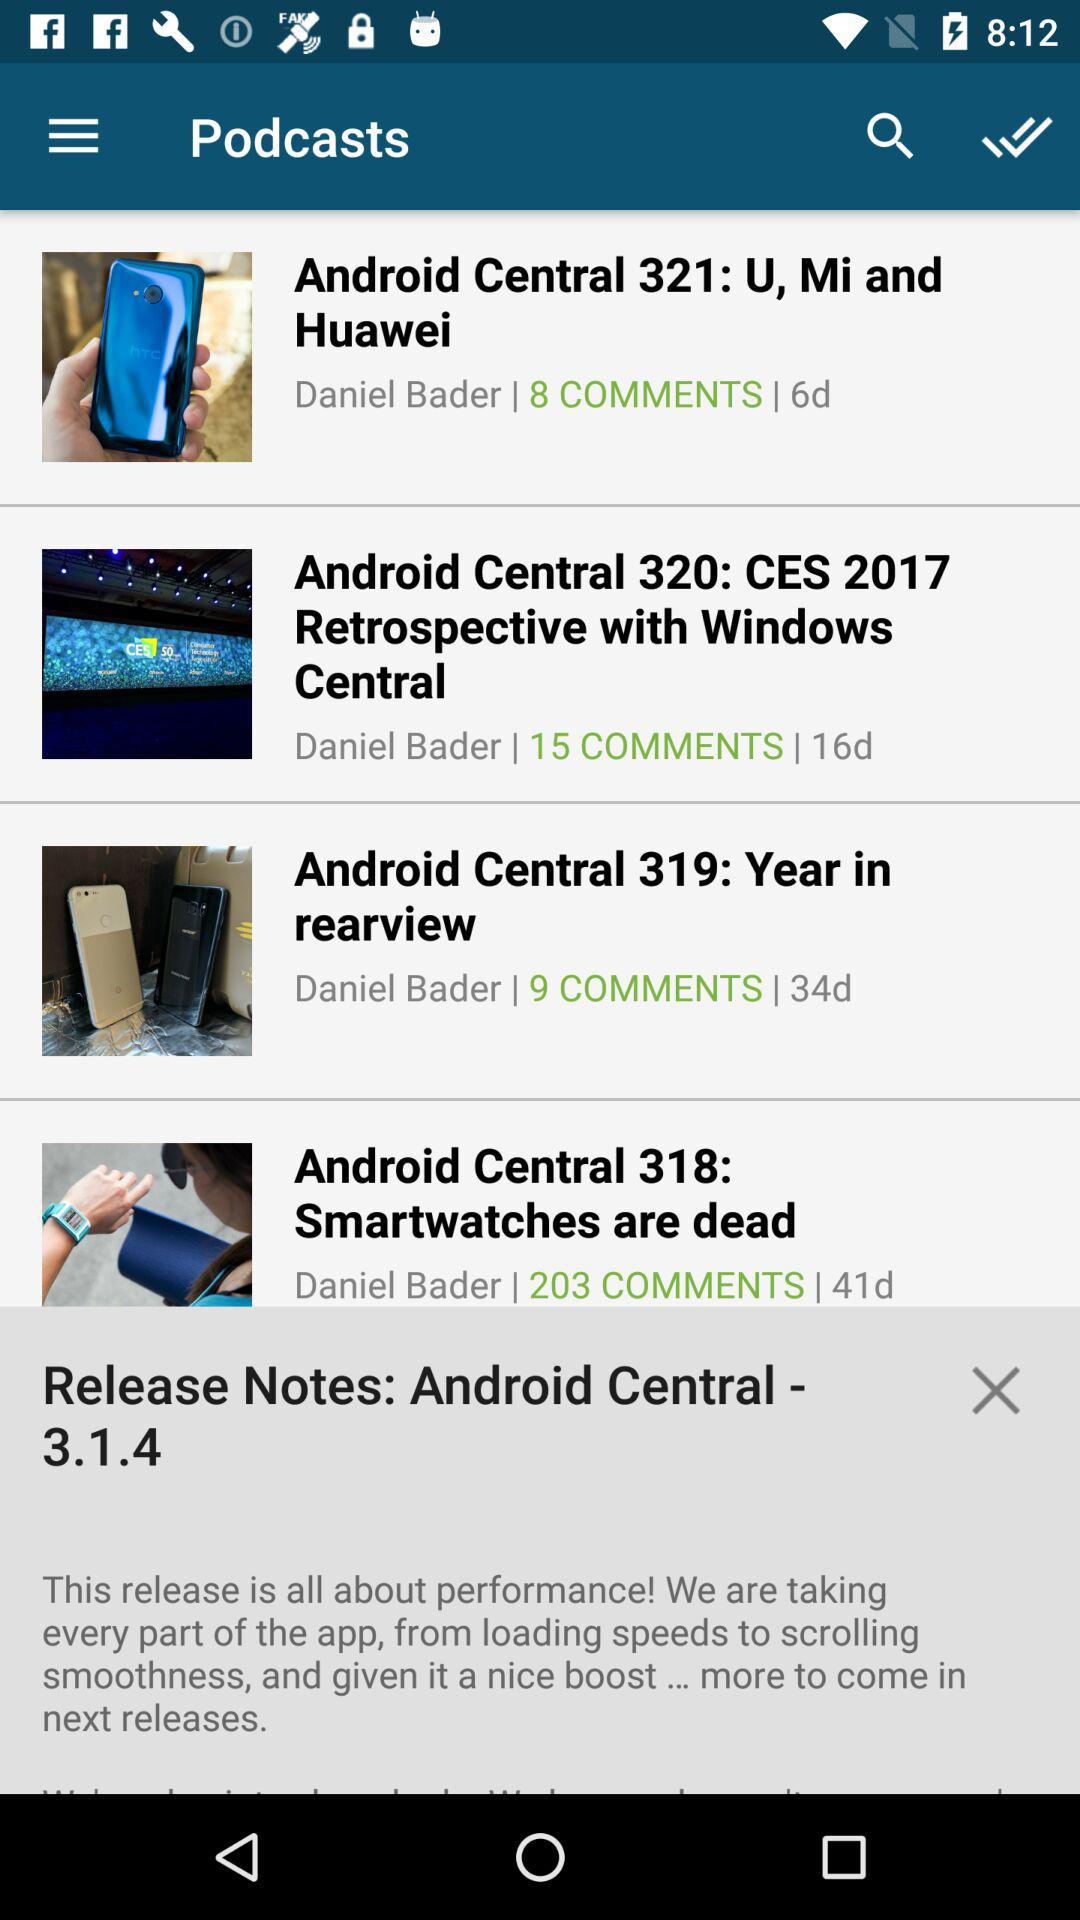What is the number of comments on the "Android Central 321: U, Mi and Huawei"? The number of comments is 8. 